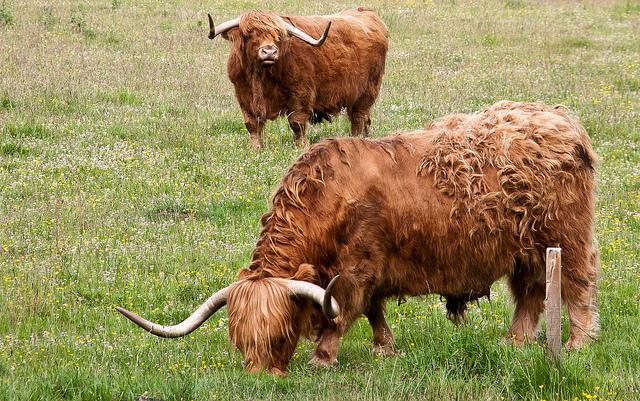What color are the animals?
Quick response, please. Brown. Which animals are they?
Write a very short answer. Yaks. Are any of the animals grazing?
Keep it brief. Yes. 